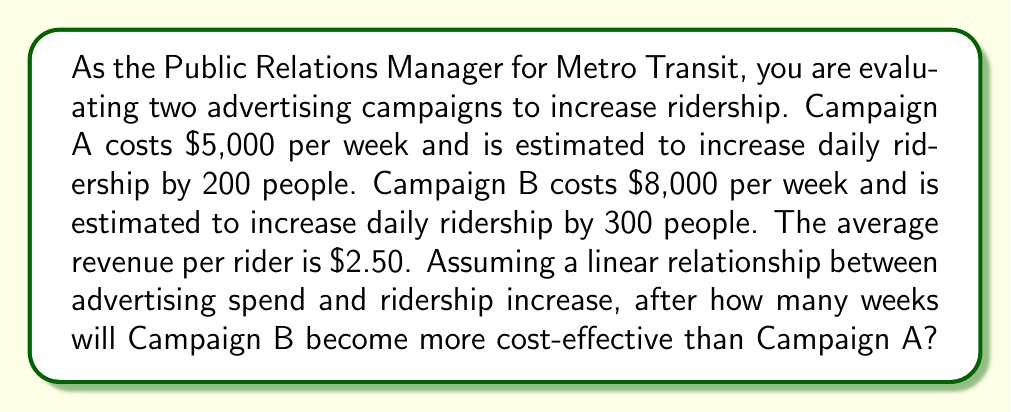Solve this math problem. Let's approach this step-by-step:

1) First, let's define our variables:
   $x$ = number of weeks
   $C_A$ = total cost of Campaign A
   $C_B$ = total cost of Campaign B
   $R_A$ = total revenue from Campaign A
   $R_B$ = total revenue from Campaign B

2) We can express the total cost of each campaign as a function of weeks:
   $C_A = 5000x$
   $C_B = 8000x$

3) Now, let's calculate the daily revenue increase for each campaign:
   Campaign A: 200 riders * $2.50 = $500 per day
   Campaign B: 300 riders * $2.50 = $750 per day

4) Assuming 7 days per week, the weekly revenue increase is:
   Campaign A: $500 * 7 = $3500 per week
   Campaign B: $750 * 7 = $5250 per week

5) We can express the total revenue of each campaign as a function of weeks:
   $R_A = 3500x$
   $R_B = 5250x$

6) The net benefit of each campaign is revenue minus cost:
   Net benefit A: $R_A - C_A = 3500x - 5000x = -1500x$
   Net benefit B: $R_B - C_B = 5250x - 8000x = -2750x$

7) Campaign B becomes more cost-effective when its net benefit exceeds that of Campaign A:
   $-2750x > -1500x$
   $-1250x > 0$
   $x > 0$

8) This inequality is always true for positive x, meaning Campaign B is always more cost-effective. However, we need to find when it becomes profitable compared to Campaign A.

9) We can do this by setting the net benefits equal:
   $-1500x = -2750x$
   $1250x = 0$
   $x = 0$

10) This means Campaign B is more cost-effective from the start, but we need to find when both campaigns break even (net benefit = 0):
    For Campaign A: $-1500x = 0$ → $x = 0$
    For Campaign B: $-2750x = 0$ → $x = 0$

11) Both campaigns start generating positive net benefits immediately after the first week.
Answer: Campaign B is more cost-effective than Campaign A from the start (week 0). Both campaigns begin generating positive net benefits after the first week. 